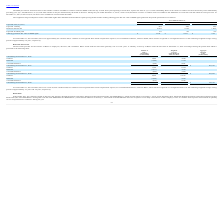From Ringcentral's financial document, As of December 31, 2019 and 2018, what are the respective number of unrecognized share-based compensation expense, net of estimated forfeitures, related to ESPP? The document shows two values: $2.3 million and $1.5 million. From the document: "and 2018, there was approximately $2.3 million and $1.5 million of unrecognized share-based compensation expense, net of estimated forfeitures, relate..." Also, What are the respective expected volatility of ESPP rights for the year ended December 31, 2019 and 2018? The document shows two values: 47% and 42%. From the document: "Expected volatility 47% 42% 34% Expected volatility 47% 42% 34%..." Also, What are the respective expected volatility of ESPP rights for the year ended December 31, 2018 and 2017? The document shows two values: 42% and 34%. From the document: "Expected volatility 47% 42% 34% Expected volatility 47% 42% 34%..." Also, can you calculate: What is the percentage change in the offering grant date fair value of ESPP rights between 2017 and 2018? To answer this question, I need to perform calculations using the financial data. The calculation is: (18.07 - 9.52)/9.52 , which equals 89.81 (percentage). This is based on the information: "date fair value of ESPP rights $ 33.66 $ 18.07 $ 9.52 ng grant date fair value of ESPP rights $ 33.66 $ 18.07 $ 9.52..." The key data points involved are: 18.07, 9.52. Also, can you calculate: What is the percentage change in the offering grant date fair value of ESPP rights between 2018 and 2019? To answer this question, I need to perform calculations using the financial data. The calculation is: (33.66 - 18.07)/18.07 , which equals 86.28 (percentage). This is based on the information: "Offering grant date fair value of ESPP rights $ 33.66 $ 18.07 $ 9.52 ng grant date fair value of ESPP rights $ 33.66 $ 18.07 $ 9.52..." The key data points involved are: 18.07, 33.66. Also, can you calculate: What is the average offering grant date fair value of ESPP rights between 2017 to 2019? To answer this question, I need to perform calculations using the financial data. The calculation is: (33.66 + 18.07 + 9.52)/3 , which equals 20.42. This is based on the information: "date fair value of ESPP rights $ 33.66 $ 18.07 $ 9.52 Offering grant date fair value of ESPP rights $ 33.66 $ 18.07 $ 9.52 ng grant date fair value of ESPP rights $ 33.66 $ 18.07 $ 9.52..." The key data points involved are: 18.07, 33.66, 9.52. 